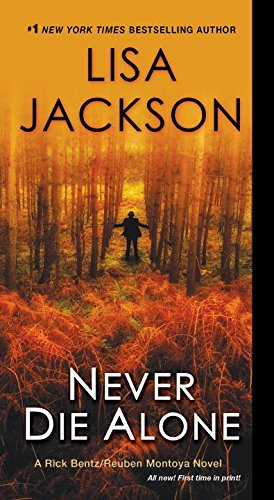What type of book is this? This book belongs to the Mystery, Thriller & Suspense genres, offering a compelling narrative that keeps readers on the edge of their seats. 